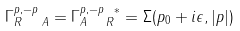Convert formula to latex. <formula><loc_0><loc_0><loc_500><loc_500>\Gamma _ { R \ \ A } ^ { p , - p } = \Gamma _ { A \ \ R } ^ { p , - p \ \ast } = \Sigma ( p _ { 0 } + i \epsilon , | { p } | )</formula> 